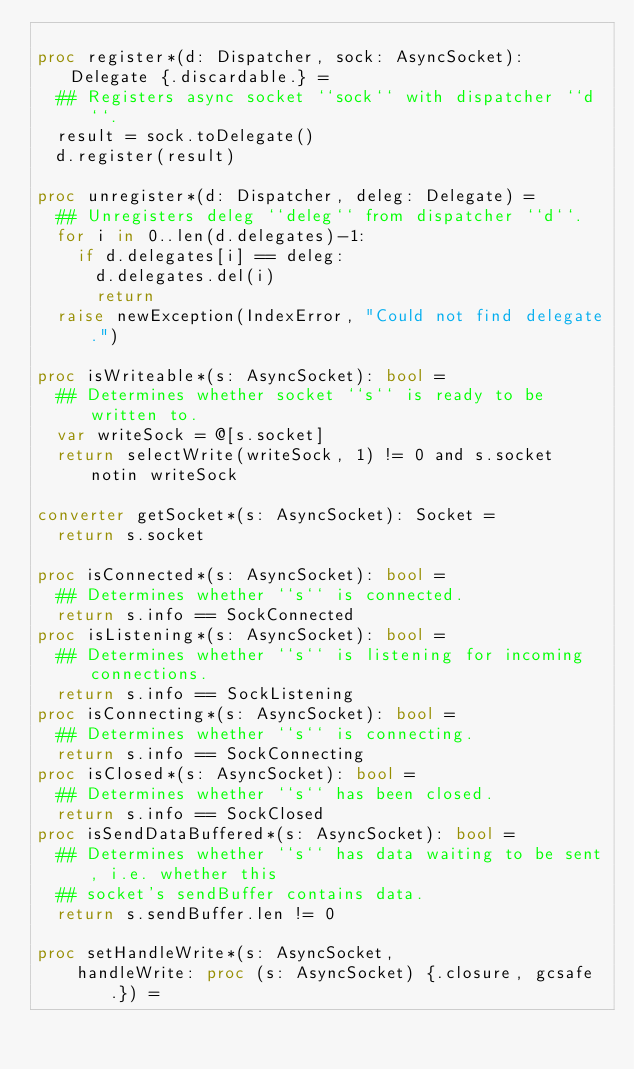<code> <loc_0><loc_0><loc_500><loc_500><_Nim_>
proc register*(d: Dispatcher, sock: AsyncSocket): Delegate {.discardable.} =
  ## Registers async socket ``sock`` with dispatcher ``d``.
  result = sock.toDelegate()
  d.register(result)

proc unregister*(d: Dispatcher, deleg: Delegate) =
  ## Unregisters deleg ``deleg`` from dispatcher ``d``.
  for i in 0..len(d.delegates)-1:
    if d.delegates[i] == deleg:
      d.delegates.del(i)
      return
  raise newException(IndexError, "Could not find delegate.")

proc isWriteable*(s: AsyncSocket): bool =
  ## Determines whether socket ``s`` is ready to be written to.
  var writeSock = @[s.socket]
  return selectWrite(writeSock, 1) != 0 and s.socket notin writeSock

converter getSocket*(s: AsyncSocket): Socket =
  return s.socket

proc isConnected*(s: AsyncSocket): bool =
  ## Determines whether ``s`` is connected.
  return s.info == SockConnected
proc isListening*(s: AsyncSocket): bool =
  ## Determines whether ``s`` is listening for incoming connections.
  return s.info == SockListening
proc isConnecting*(s: AsyncSocket): bool =
  ## Determines whether ``s`` is connecting.
  return s.info == SockConnecting
proc isClosed*(s: AsyncSocket): bool =
  ## Determines whether ``s`` has been closed.
  return s.info == SockClosed
proc isSendDataBuffered*(s: AsyncSocket): bool =
  ## Determines whether ``s`` has data waiting to be sent, i.e. whether this
  ## socket's sendBuffer contains data.
  return s.sendBuffer.len != 0

proc setHandleWrite*(s: AsyncSocket,
    handleWrite: proc (s: AsyncSocket) {.closure, gcsafe.}) =</code> 